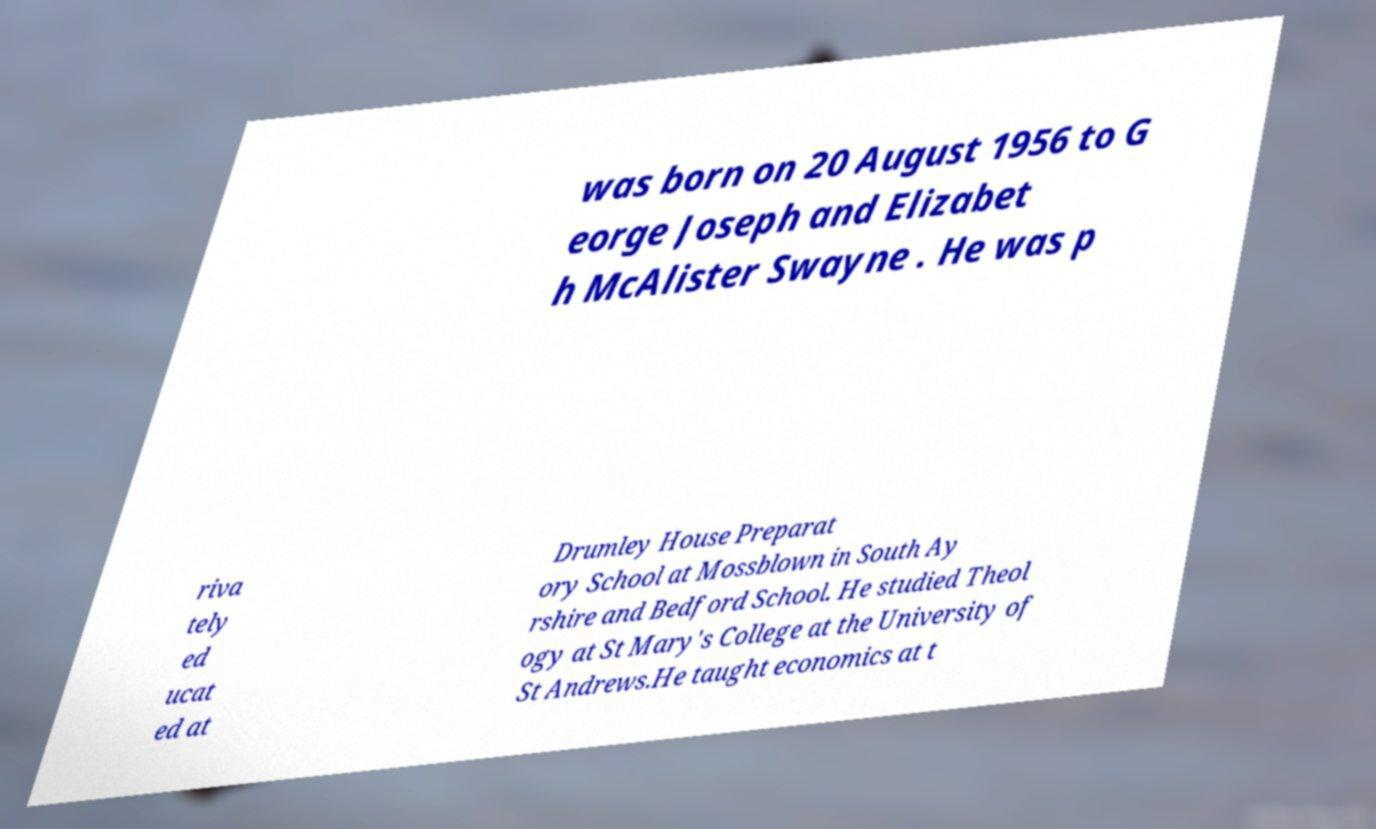Can you read and provide the text displayed in the image?This photo seems to have some interesting text. Can you extract and type it out for me? was born on 20 August 1956 to G eorge Joseph and Elizabet h McAlister Swayne . He was p riva tely ed ucat ed at Drumley House Preparat ory School at Mossblown in South Ay rshire and Bedford School. He studied Theol ogy at St Mary's College at the University of St Andrews.He taught economics at t 